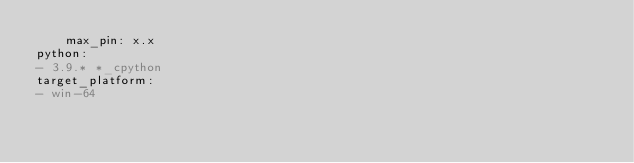<code> <loc_0><loc_0><loc_500><loc_500><_YAML_>    max_pin: x.x
python:
- 3.9.* *_cpython
target_platform:
- win-64
</code> 